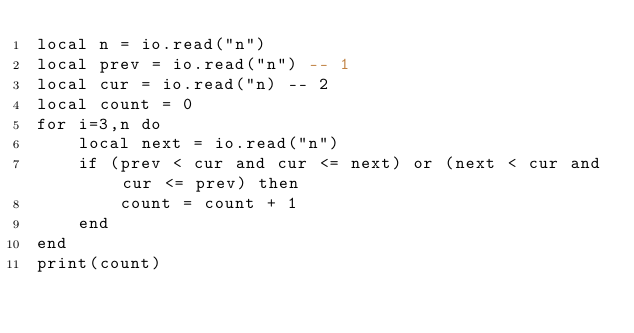Convert code to text. <code><loc_0><loc_0><loc_500><loc_500><_Lua_>local n = io.read("n")
local prev = io.read("n") -- 1
local cur = io.read("n) -- 2
local count = 0
for i=3,n do
    local next = io.read("n")
    if (prev < cur and cur <= next) or (next < cur and cur <= prev) then
        count = count + 1
    end
end
print(count)</code> 